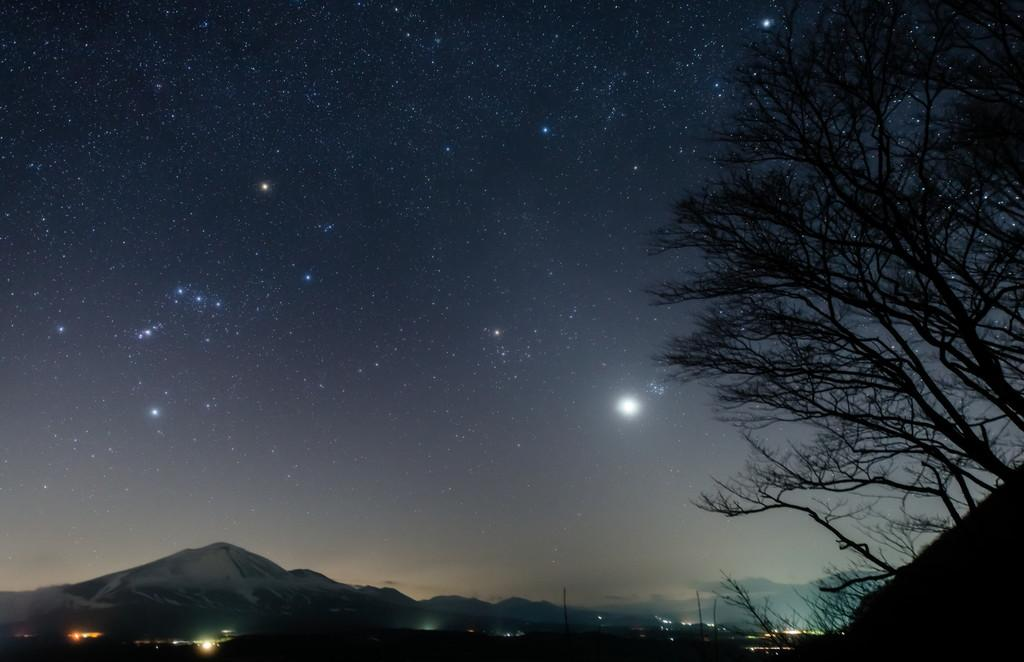What type of trees can be seen on the right side of the image? There are deciduous trees on the right side of the image. What natural features are visible in the background of the image? Mountains are visible in the background of the image. What celestial objects can be seen in the sky? The moon and stars are visible in the sky. What type of linen is draped over the kitten in the image? There is no kitten or linen present in the image. How many letters are visible on the mountains in the image? There are no letters visible on the mountains in the image. 